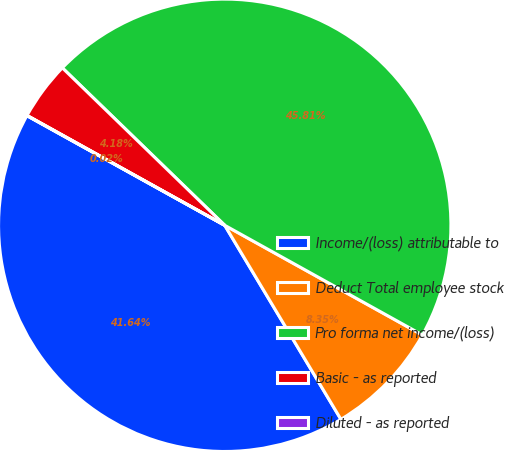Convert chart. <chart><loc_0><loc_0><loc_500><loc_500><pie_chart><fcel>Income/(loss) attributable to<fcel>Deduct Total employee stock<fcel>Pro forma net income/(loss)<fcel>Basic - as reported<fcel>Diluted - as reported<nl><fcel>41.64%<fcel>8.35%<fcel>45.81%<fcel>4.18%<fcel>0.02%<nl></chart> 